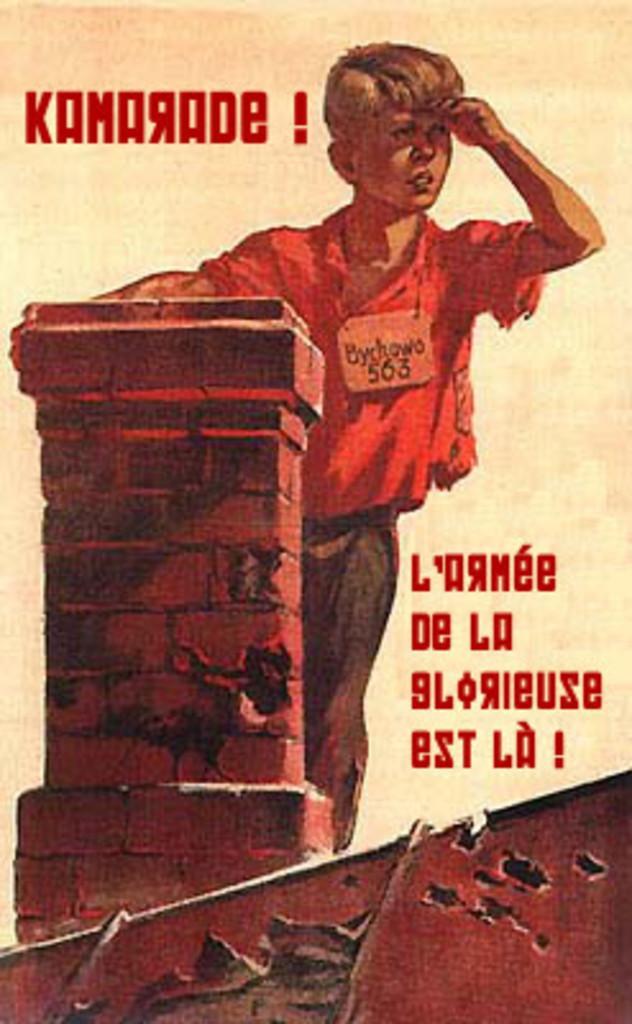Describe this image in one or two sentences. In this image we can see a painting. 